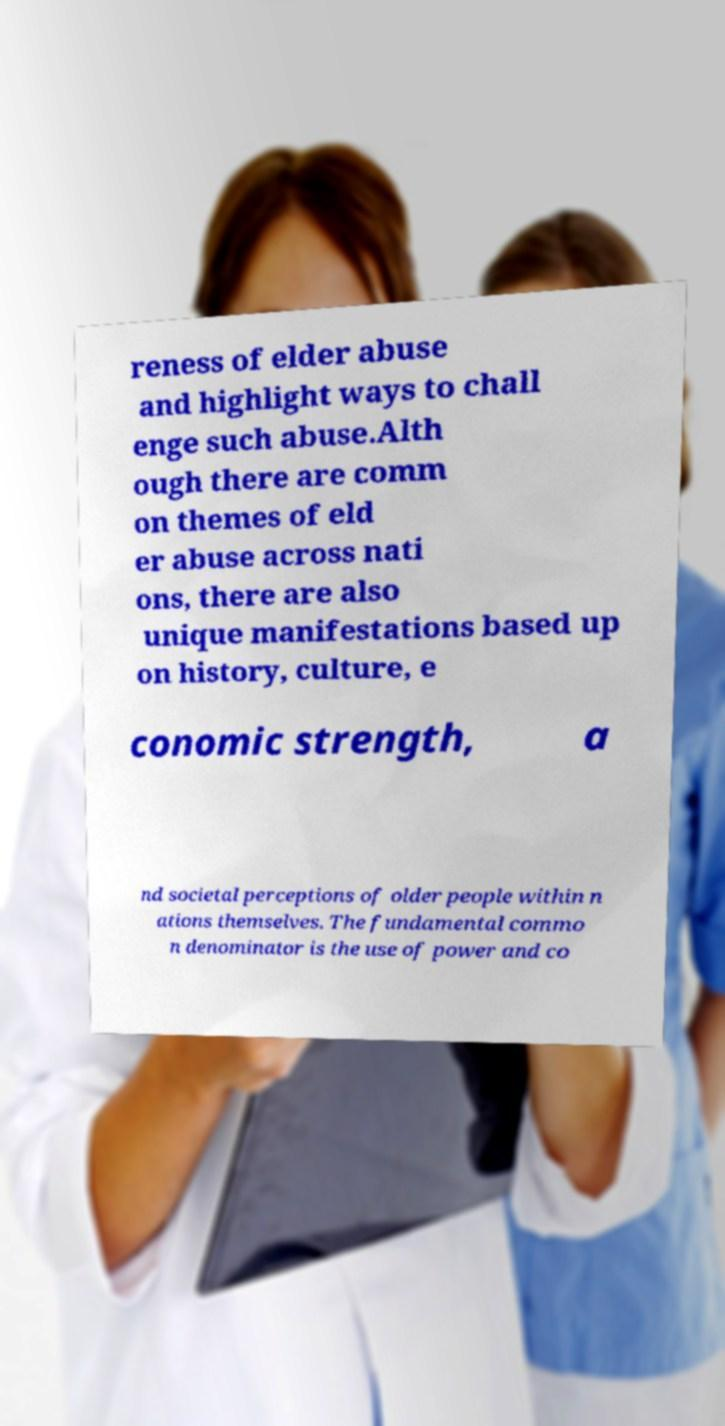I need the written content from this picture converted into text. Can you do that? reness of elder abuse and highlight ways to chall enge such abuse.Alth ough there are comm on themes of eld er abuse across nati ons, there are also unique manifestations based up on history, culture, e conomic strength, a nd societal perceptions of older people within n ations themselves. The fundamental commo n denominator is the use of power and co 